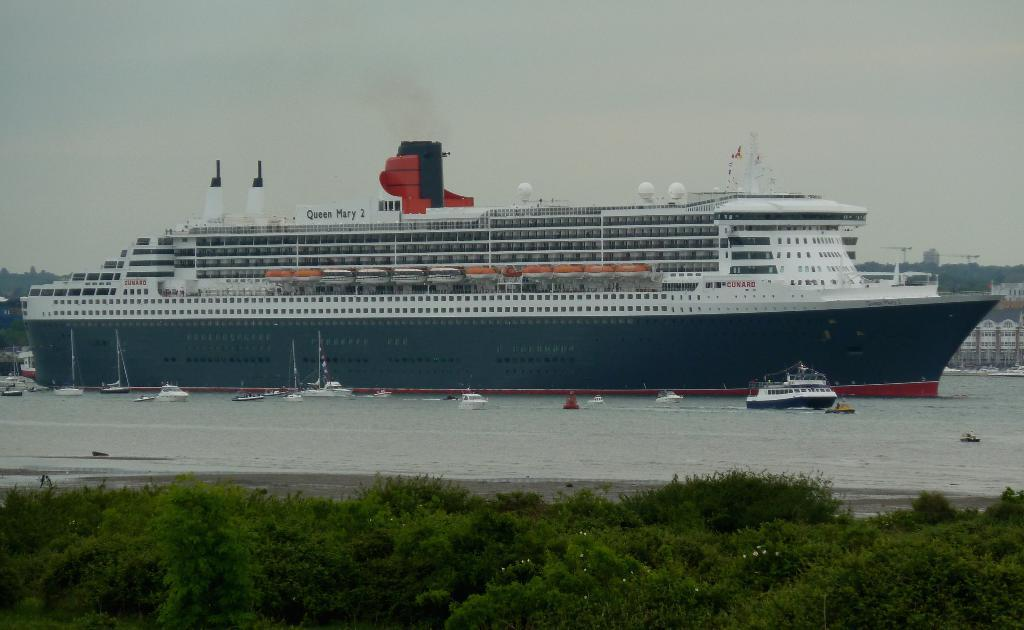What is the main subject of the image? The main subject of the image is a ship. Where is the ship located? The ship is on the sea. What else can be seen in the image besides the ship? There are plants visible in the image. What type of rifle is being used by the actor on the train in the image? There is no train, actor, or rifle present in the image; it features a ship on the sea with plants visible. 